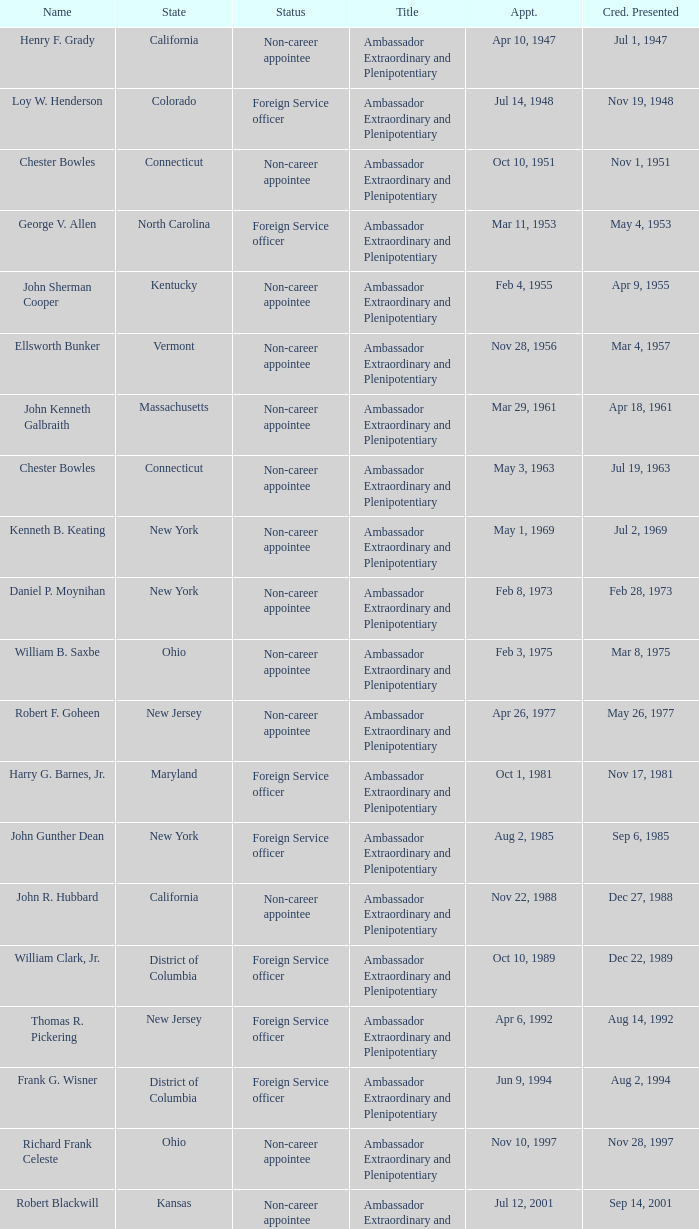What day were credentials presented for vermont? Mar 4, 1957. 